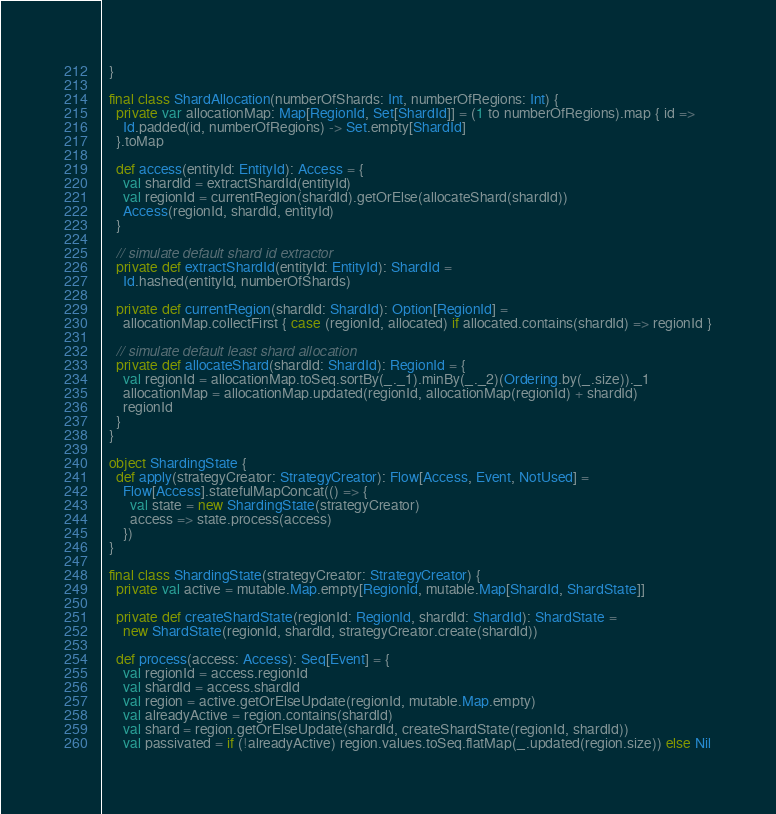Convert code to text. <code><loc_0><loc_0><loc_500><loc_500><_Scala_>  }

  final class ShardAllocation(numberOfShards: Int, numberOfRegions: Int) {
    private var allocationMap: Map[RegionId, Set[ShardId]] = (1 to numberOfRegions).map { id =>
      Id.padded(id, numberOfRegions) -> Set.empty[ShardId]
    }.toMap

    def access(entityId: EntityId): Access = {
      val shardId = extractShardId(entityId)
      val regionId = currentRegion(shardId).getOrElse(allocateShard(shardId))
      Access(regionId, shardId, entityId)
    }

    // simulate default shard id extractor
    private def extractShardId(entityId: EntityId): ShardId =
      Id.hashed(entityId, numberOfShards)

    private def currentRegion(shardId: ShardId): Option[RegionId] =
      allocationMap.collectFirst { case (regionId, allocated) if allocated.contains(shardId) => regionId }

    // simulate default least shard allocation
    private def allocateShard(shardId: ShardId): RegionId = {
      val regionId = allocationMap.toSeq.sortBy(_._1).minBy(_._2)(Ordering.by(_.size))._1
      allocationMap = allocationMap.updated(regionId, allocationMap(regionId) + shardId)
      regionId
    }
  }

  object ShardingState {
    def apply(strategyCreator: StrategyCreator): Flow[Access, Event, NotUsed] =
      Flow[Access].statefulMapConcat(() => {
        val state = new ShardingState(strategyCreator)
        access => state.process(access)
      })
  }

  final class ShardingState(strategyCreator: StrategyCreator) {
    private val active = mutable.Map.empty[RegionId, mutable.Map[ShardId, ShardState]]

    private def createShardState(regionId: RegionId, shardId: ShardId): ShardState =
      new ShardState(regionId, shardId, strategyCreator.create(shardId))

    def process(access: Access): Seq[Event] = {
      val regionId = access.regionId
      val shardId = access.shardId
      val region = active.getOrElseUpdate(regionId, mutable.Map.empty)
      val alreadyActive = region.contains(shardId)
      val shard = region.getOrElseUpdate(shardId, createShardState(regionId, shardId))
      val passivated = if (!alreadyActive) region.values.toSeq.flatMap(_.updated(region.size)) else Nil</code> 